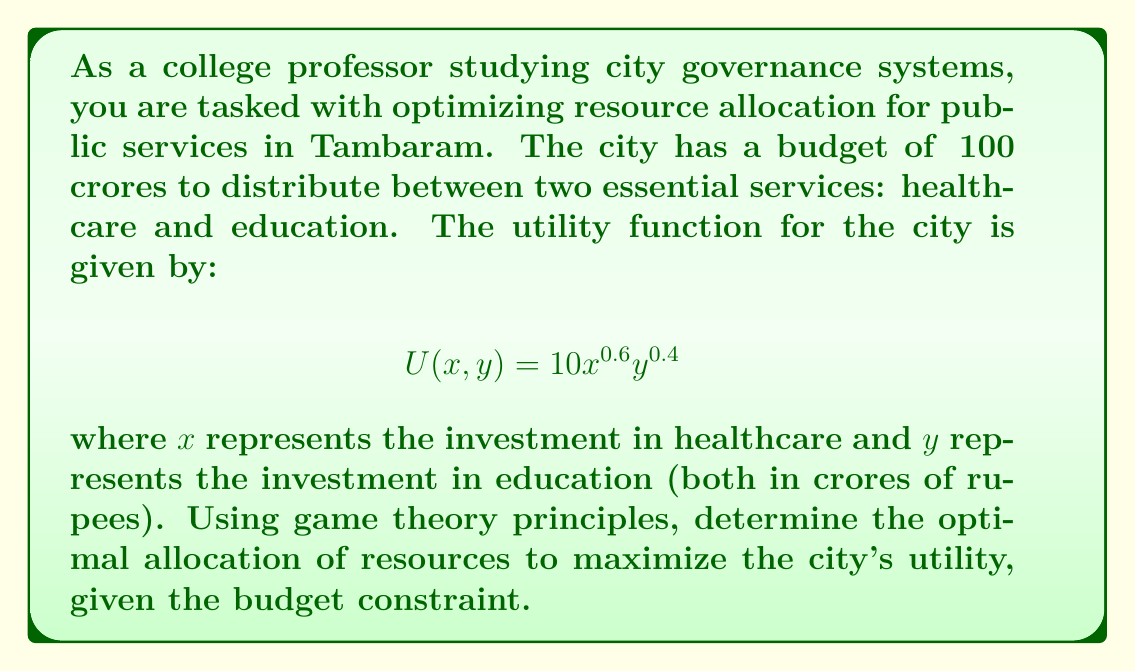What is the answer to this math problem? To solve this problem, we can use the principles of game theory and optimization. The goal is to maximize the utility function subject to the budget constraint. Let's approach this step-by-step:

1) First, we need to set up the optimization problem:

   Maximize: $U(x, y) = 10x^{0.6}y^{0.4}$
   Subject to: $x + y = 100$ (budget constraint)

2) We can use the method of Lagrange multipliers to solve this constrained optimization problem. Let's define the Lagrangian function:

   $L(x, y, \lambda) = 10x^{0.6}y^{0.4} - \lambda(x + y - 100)$

3) Now, we take partial derivatives and set them equal to zero:

   $\frac{\partial L}{\partial x} = 6x^{-0.4}y^{0.4} - \lambda = 0$
   $\frac{\partial L}{\partial y} = 4x^{0.6}y^{-0.6} - \lambda = 0$
   $\frac{\partial L}{\partial \lambda} = x + y - 100 = 0$

4) From the first two equations, we can derive:

   $6x^{-0.4}y^{0.4} = 4x^{0.6}y^{-0.6}$

5) Simplifying this equation:

   $\frac{6}{4} = \frac{x^{0.6}y^{-0.6}}{x^{-0.4}y^{0.4}} = (\frac{x}{y})^1 = \frac{x}{y}$

   Therefore, $x = 1.5y$

6) Substituting this into the budget constraint:

   $1.5y + y = 100$
   $2.5y = 100$
   $y = 40$

7) And consequently:

   $x = 1.5 * 40 = 60$

8) We can verify that this satisfies the budget constraint:

   $60 + 40 = 100$

Therefore, the optimal allocation is ₹60 crores for healthcare and ₹40 crores for education.
Answer: The optimal allocation to maximize the city's utility is ₹60 crores for healthcare and ₹40 crores for education. 